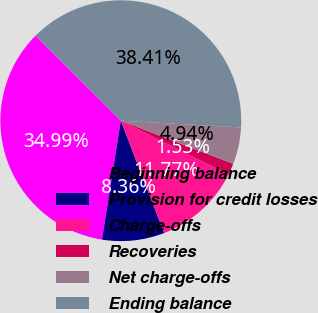<chart> <loc_0><loc_0><loc_500><loc_500><pie_chart><fcel>Beginning balance<fcel>Provision for credit losses<fcel>Charge-offs<fcel>Recoveries<fcel>Net charge-offs<fcel>Ending balance<nl><fcel>34.99%<fcel>8.36%<fcel>11.77%<fcel>1.53%<fcel>4.94%<fcel>38.41%<nl></chart> 